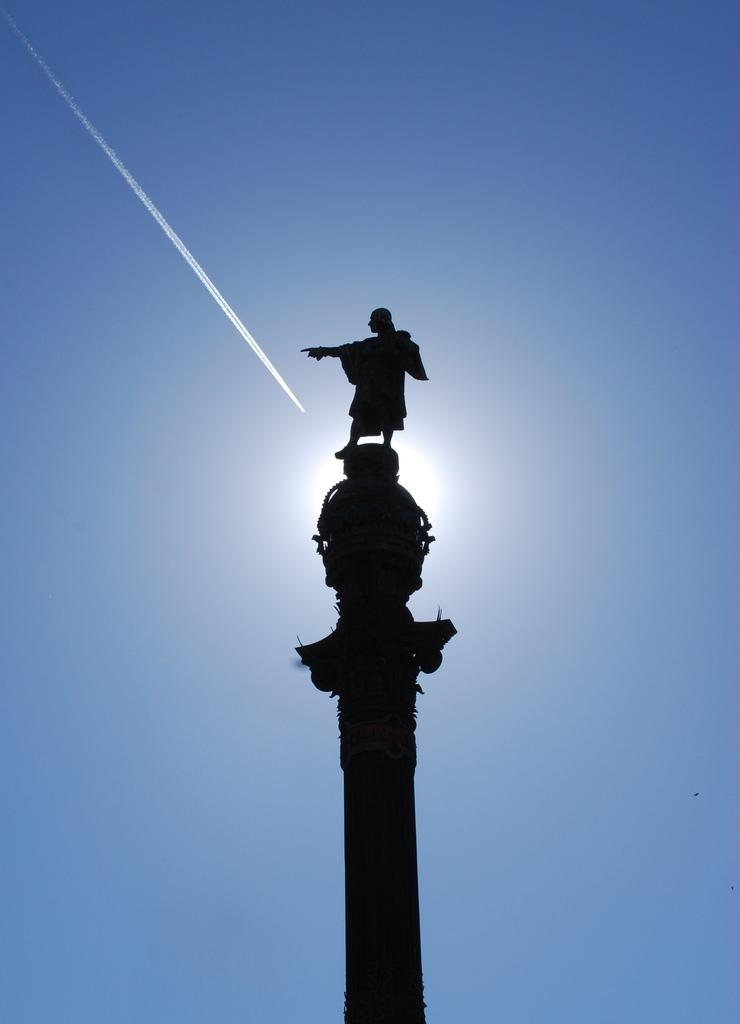What is the main subject in the foreground of the image? There is a sculpture on a pole in the foreground of the image. What can be seen in the background of the image? There is rocket smoke in the sky in the background of the image. How many rings are visible on the sculpture in the image? There is no mention of rings on the sculpture in the provided facts, so we cannot determine the number of rings from the image. 